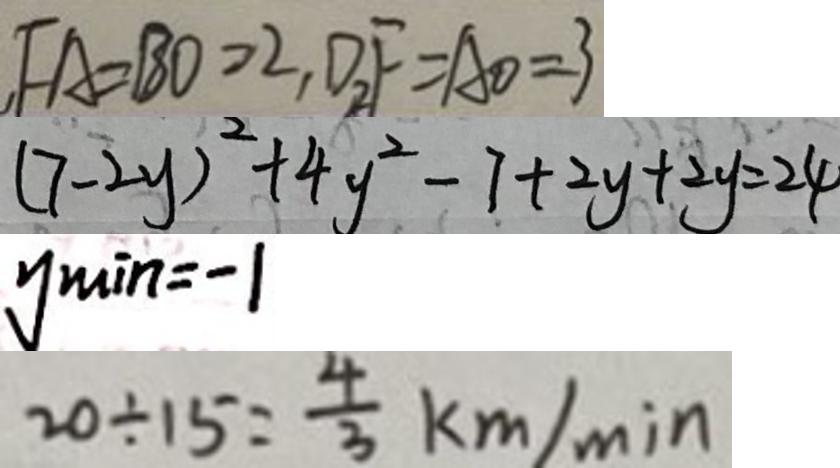<formula> <loc_0><loc_0><loc_500><loc_500>, F A = B O = 2 , D F = A O = 3 
 ( 7 - 2 y ) ^ { 2 } + 4 y ^ { 2 } - 7 + 2 y + 2 y = 2 4 
 y \min = - 1 
 2 0 \div 1 5 = \frac { 4 } { 3 } k m / \min</formula> 